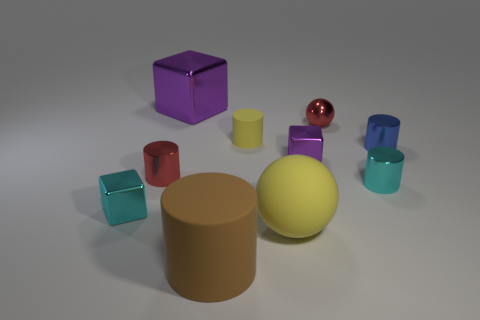What material is the cylinder that is both behind the small red metal cylinder and on the left side of the tiny blue shiny thing? The cylinder in question appears to have a matte texture and an earthy brown color, which is commonly associated with cardboard or dense paper materials; it does not exhibit the typical sheen or texture of rubber. 